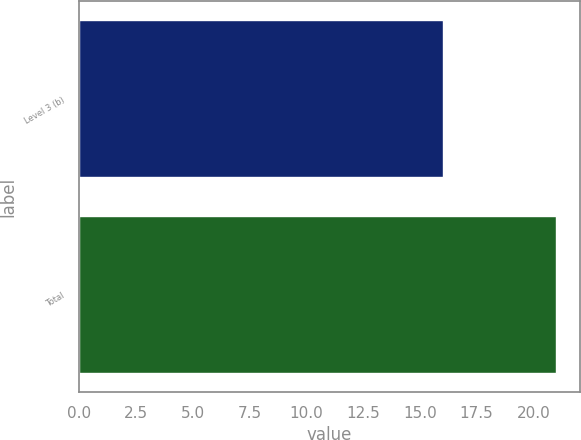Convert chart. <chart><loc_0><loc_0><loc_500><loc_500><bar_chart><fcel>Level 3 (b)<fcel>Total<nl><fcel>16<fcel>21<nl></chart> 